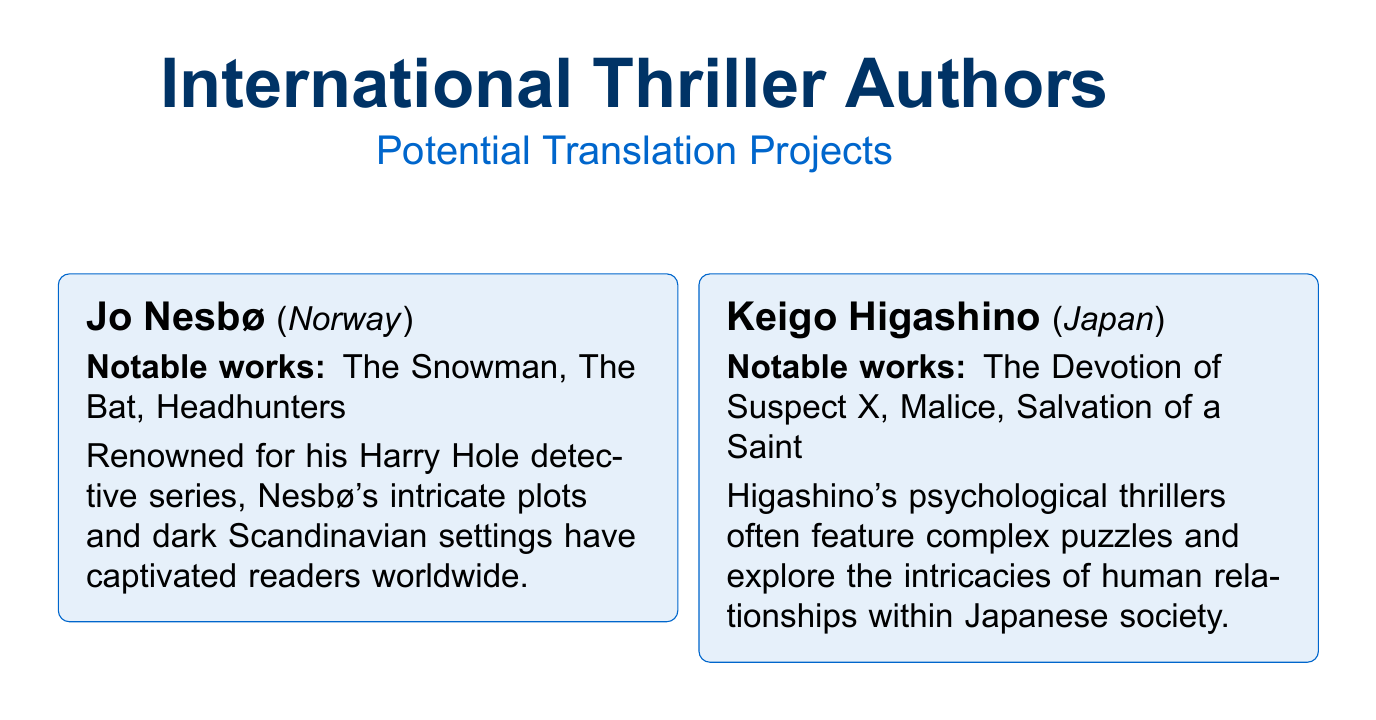What is Jo Nesbø's notable work? Jo Nesbø's notable works include "The Snowman," "The Bat," and "Headhunters."
Answer: The Snowman Which country is Keigo Higashino from? Keigo Higashino is from Japan, as specified in the authors' section of the document.
Answer: Japan How many notable works are listed for Fred Vargas? Fred Vargas has three notable works listed: "Have Mercy on Us All," "Seeking Whom He May Devour," and "The Chalk Circle Man."
Answer: Three What thematic element does Kanae Minato explore in her thrillers? Kanae Minato's thrillers often explore themes of revenge and the darker aspects of human nature.
Answer: Revenge What is one marketing point mentioned in the document? One marketing point highlighted is the opportunity to introduce unique cultural perspectives to English-speaking readers.
Answer: Unique cultural perspectives Which author is associated with a gritty portrayal of Icelandic society? Arnaldur Indriðason is known for offering a gritty portrayal of Icelandic society in his works.
Answer: Arnaldur Indriðason What should be balanced in the translation considerations? The translation considerations mention balancing faithfulness to the original text with readability for the target audience.
Answer: Faithfulness and readability What genre do all the listed authors primarily write in? The listed authors primarily write in the thriller genre, as indicated throughout the document.
Answer: Thriller 